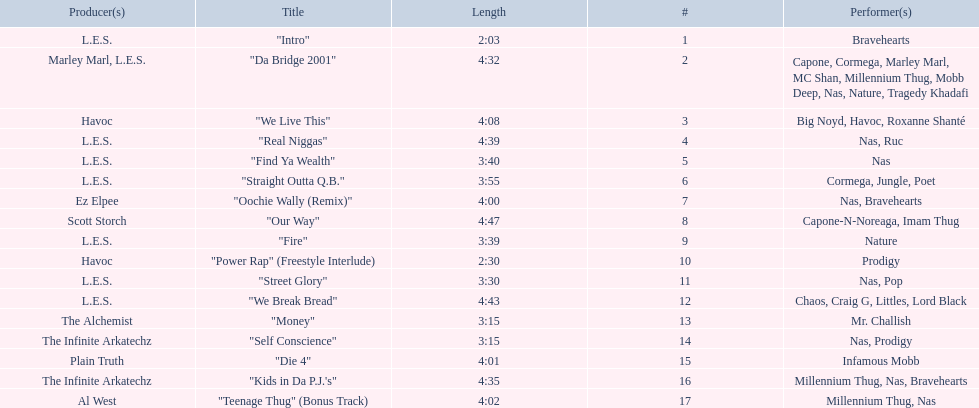What's the length of the least lengthy tune on the album? 2:03. Help me parse the entirety of this table. {'header': ['Producer(s)', 'Title', 'Length', '#', 'Performer(s)'], 'rows': [['L.E.S.', '"Intro"', '2:03', '1', 'Bravehearts'], ['Marley Marl, L.E.S.', '"Da Bridge 2001"', '4:32', '2', 'Capone, Cormega, Marley Marl, MC Shan, Millennium Thug, Mobb Deep, Nas, Nature, Tragedy Khadafi'], ['Havoc', '"We Live This"', '4:08', '3', 'Big Noyd, Havoc, Roxanne Shanté'], ['L.E.S.', '"Real Niggas"', '4:39', '4', 'Nas, Ruc'], ['L.E.S.', '"Find Ya Wealth"', '3:40', '5', 'Nas'], ['L.E.S.', '"Straight Outta Q.B."', '3:55', '6', 'Cormega, Jungle, Poet'], ['Ez Elpee', '"Oochie Wally (Remix)"', '4:00', '7', 'Nas, Bravehearts'], ['Scott Storch', '"Our Way"', '4:47', '8', 'Capone-N-Noreaga, Imam Thug'], ['L.E.S.', '"Fire"', '3:39', '9', 'Nature'], ['Havoc', '"Power Rap" (Freestyle Interlude)', '2:30', '10', 'Prodigy'], ['L.E.S.', '"Street Glory"', '3:30', '11', 'Nas, Pop'], ['L.E.S.', '"We Break Bread"', '4:43', '12', 'Chaos, Craig G, Littles, Lord Black'], ['The Alchemist', '"Money"', '3:15', '13', 'Mr. Challish'], ['The Infinite Arkatechz', '"Self Conscience"', '3:15', '14', 'Nas, Prodigy'], ['Plain Truth', '"Die 4"', '4:01', '15', 'Infamous Mobb'], ['The Infinite Arkatechz', '"Kids in Da P.J.\'s"', '4:35', '16', 'Millennium Thug, Nas, Bravehearts'], ['Al West', '"Teenage Thug" (Bonus Track)', '4:02', '17', 'Millennium Thug, Nas']]} 